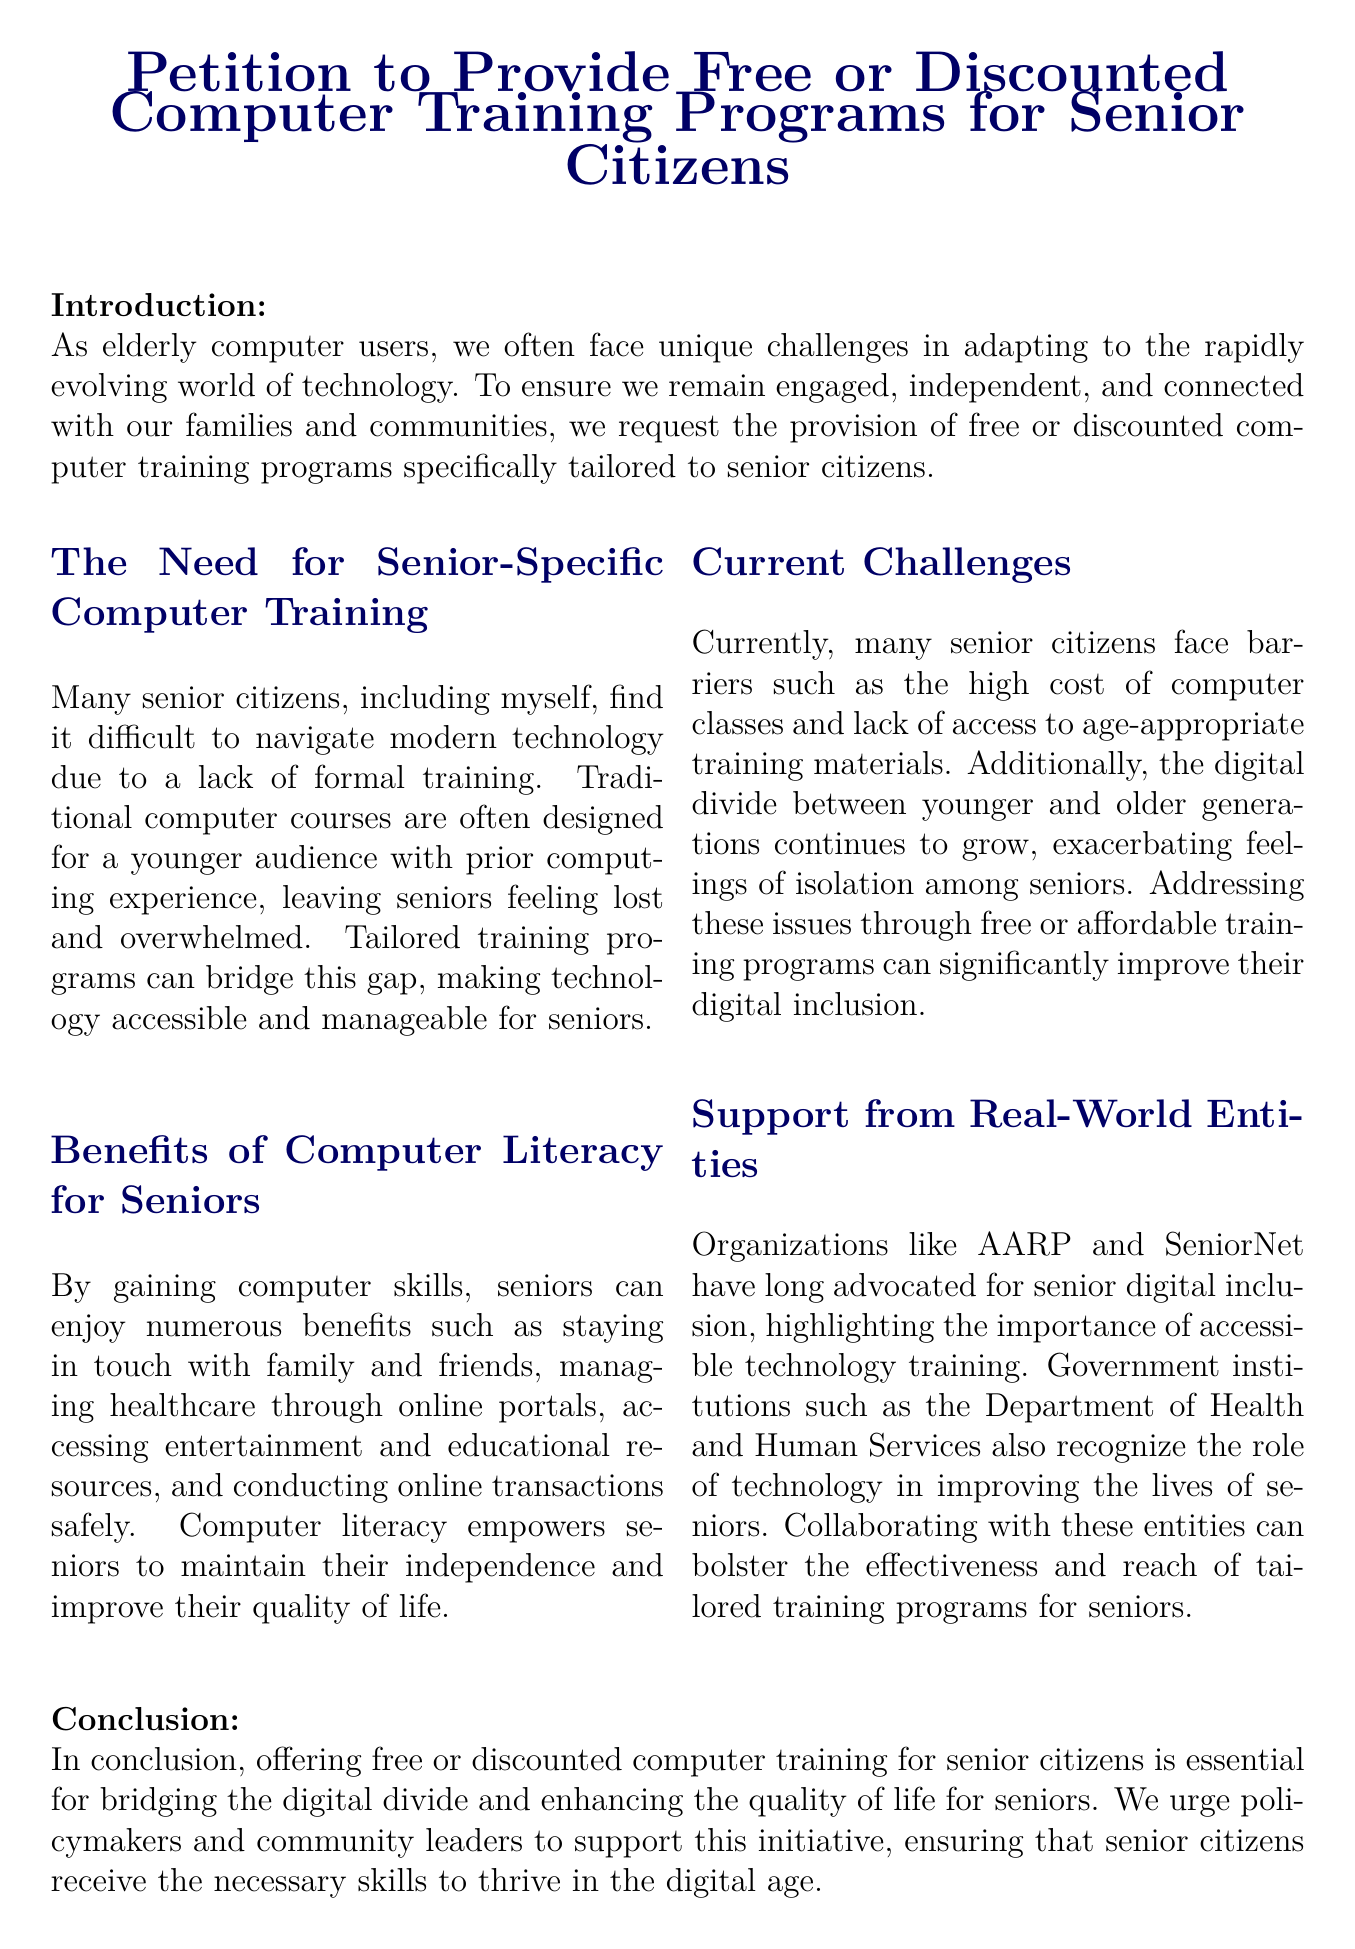What is the title of the petition? The title of the petition is clearly stated at the top of the document.
Answer: Petition to Provide Free or Discounted Computer Training Programs for Senior Citizens What are the main benefits of computer literacy for seniors? The document lists several benefits under the relevant section.
Answer: Staying in touch with family and friends, managing healthcare, accessing resources, conducting transactions safely Which organizations support senior digital inclusion? The document mentions specific organizations that advocate for this cause.
Answer: AARP and SeniorNet What are the current challenges faced by senior citizens in accessing computer training? The document details the barriers that seniors encounter in the relevant section.
Answer: High cost of classes and lack of access to age-appropriate training materials What type of action does the petition call for? The call to action details what is being requested from various entities.
Answer: Create and provide free or discounted computer training programs Which government institution recognizes the role of technology in seniors' lives? The document names a specific government institution that supports this initiative.
Answer: Department of Health and Human Services What is one of the unique challenges seniors experience with traditional computer courses? The document highlights a specific issue in the training approach for seniors.
Answer: Designed for a younger audience What is mentioned as a consequence of the growing digital divide? The document describes an effect of the increasing gap in technology access between age groups.
Answer: Feelings of isolation among seniors What does the conclusion urge policymakers to do? The conclusion summarizes the main request of the petition.
Answer: Support this initiative 